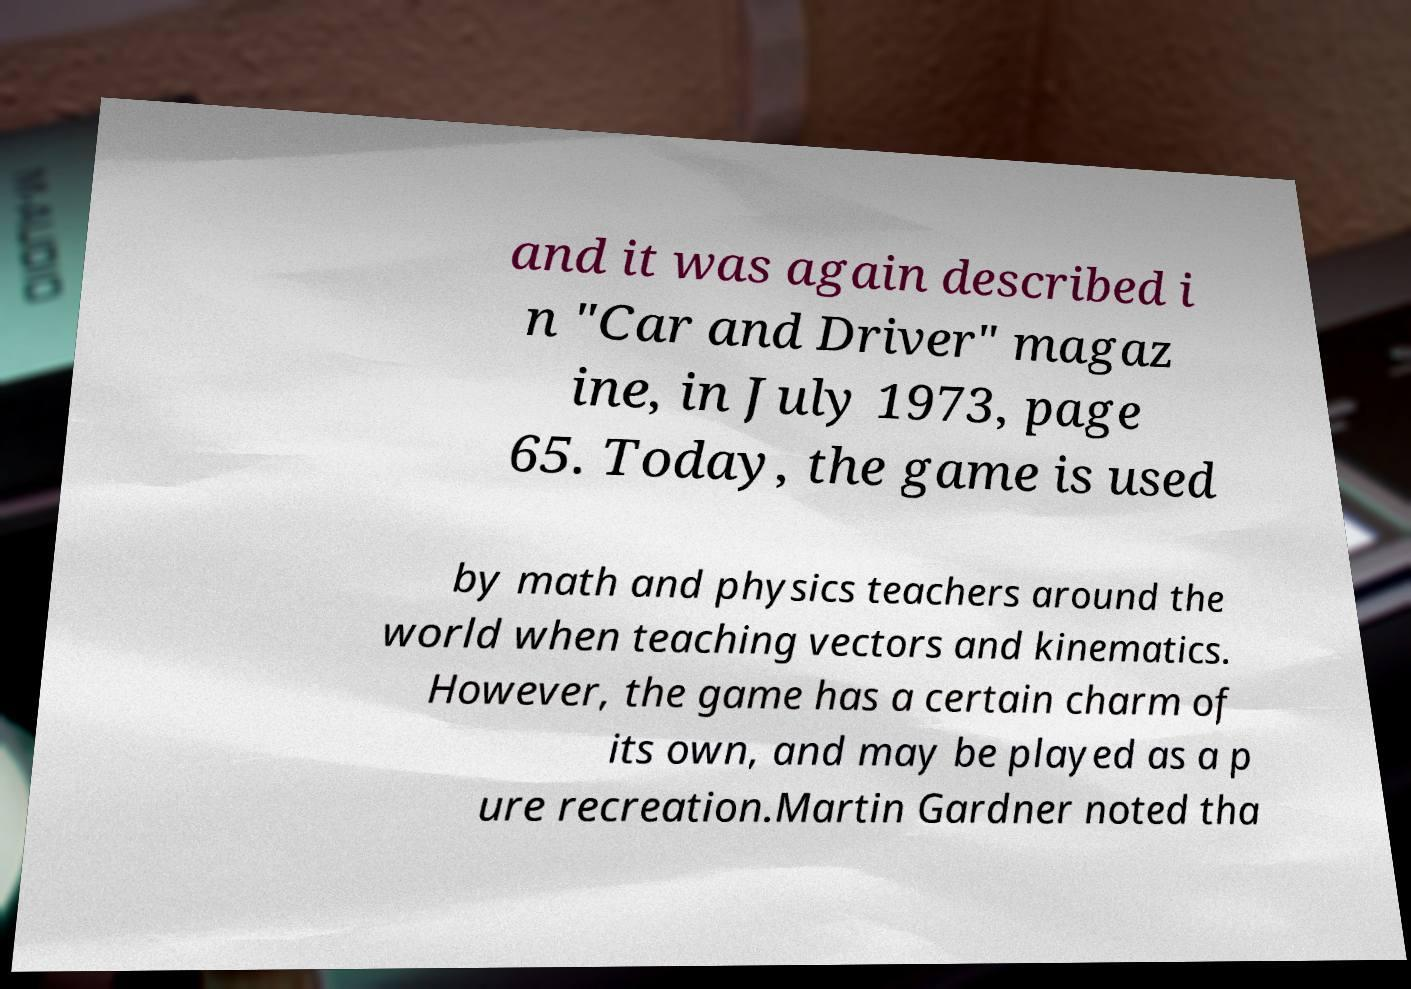There's text embedded in this image that I need extracted. Can you transcribe it verbatim? and it was again described i n "Car and Driver" magaz ine, in July 1973, page 65. Today, the game is used by math and physics teachers around the world when teaching vectors and kinematics. However, the game has a certain charm of its own, and may be played as a p ure recreation.Martin Gardner noted tha 